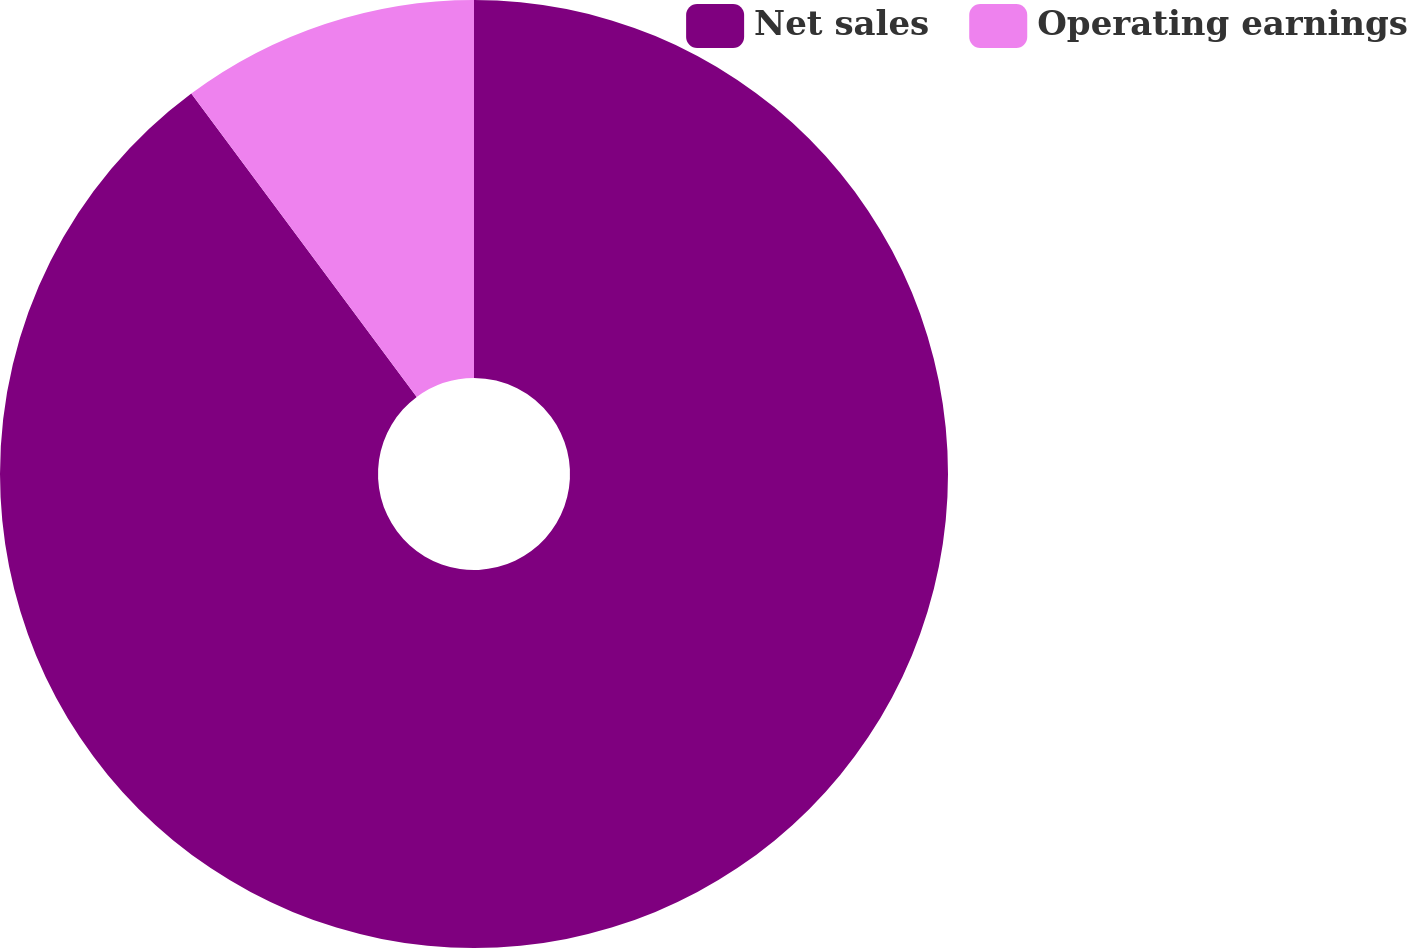Convert chart to OTSL. <chart><loc_0><loc_0><loc_500><loc_500><pie_chart><fcel>Net sales<fcel>Operating earnings<nl><fcel>89.83%<fcel>10.17%<nl></chart> 